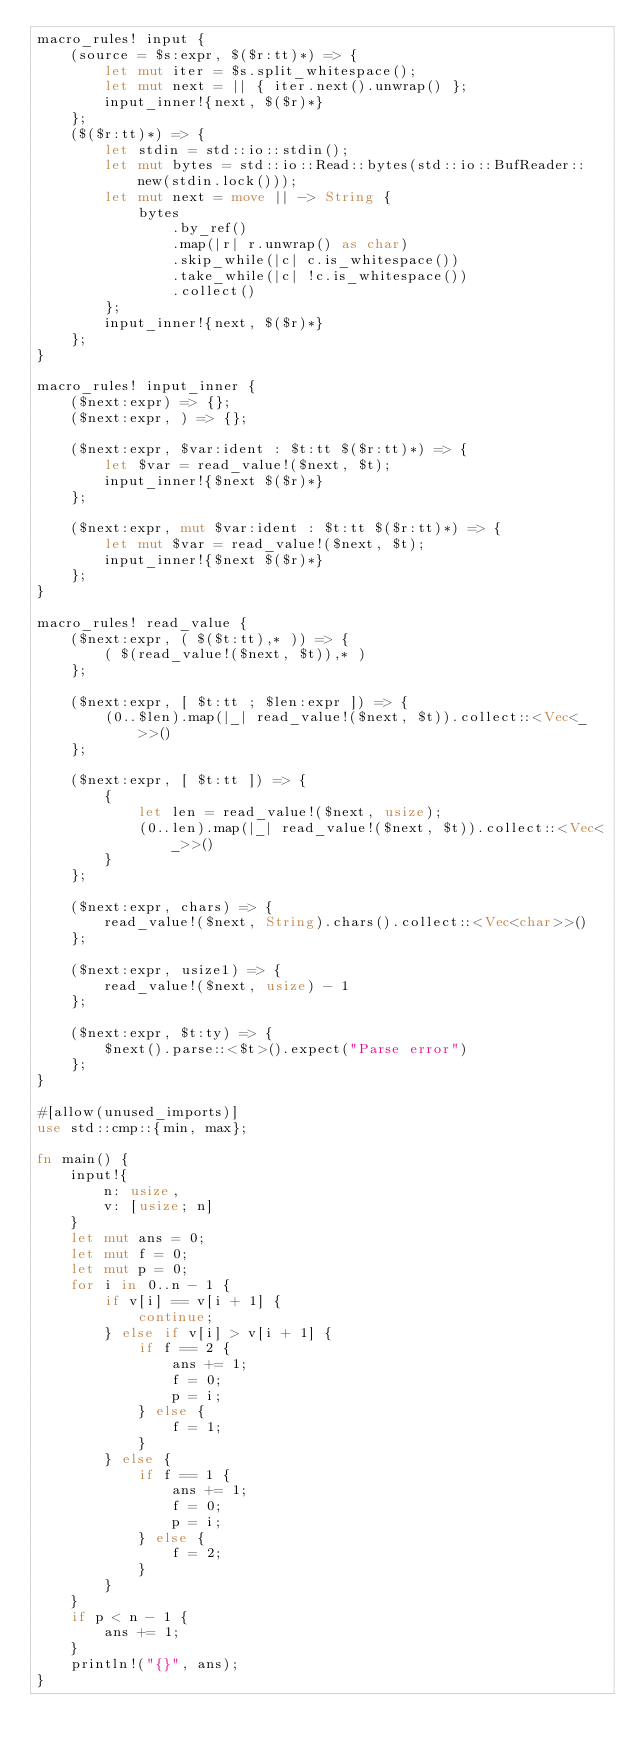<code> <loc_0><loc_0><loc_500><loc_500><_Rust_>macro_rules! input {
    (source = $s:expr, $($r:tt)*) => {
        let mut iter = $s.split_whitespace();
        let mut next = || { iter.next().unwrap() };
        input_inner!{next, $($r)*}
    };
    ($($r:tt)*) => {
        let stdin = std::io::stdin();
        let mut bytes = std::io::Read::bytes(std::io::BufReader::new(stdin.lock()));
        let mut next = move || -> String {
            bytes
                .by_ref()
                .map(|r| r.unwrap() as char)
                .skip_while(|c| c.is_whitespace())
                .take_while(|c| !c.is_whitespace())
                .collect()
        };
        input_inner!{next, $($r)*}
    };
}

macro_rules! input_inner {
    ($next:expr) => {};
    ($next:expr, ) => {};

    ($next:expr, $var:ident : $t:tt $($r:tt)*) => {
        let $var = read_value!($next, $t);
        input_inner!{$next $($r)*}
    };

    ($next:expr, mut $var:ident : $t:tt $($r:tt)*) => {
        let mut $var = read_value!($next, $t);
        input_inner!{$next $($r)*}
    };
}

macro_rules! read_value {
    ($next:expr, ( $($t:tt),* )) => {
        ( $(read_value!($next, $t)),* )
    };

    ($next:expr, [ $t:tt ; $len:expr ]) => {
        (0..$len).map(|_| read_value!($next, $t)).collect::<Vec<_>>()
    };

    ($next:expr, [ $t:tt ]) => {
        {
            let len = read_value!($next, usize);
            (0..len).map(|_| read_value!($next, $t)).collect::<Vec<_>>()
        }
    };

    ($next:expr, chars) => {
        read_value!($next, String).chars().collect::<Vec<char>>()
    };

    ($next:expr, usize1) => {
        read_value!($next, usize) - 1
    };

    ($next:expr, $t:ty) => {
        $next().parse::<$t>().expect("Parse error")
    };
}

#[allow(unused_imports)]
use std::cmp::{min, max};

fn main() {
    input!{
        n: usize,
        v: [usize; n]
    }
    let mut ans = 0;
    let mut f = 0;
    let mut p = 0;
    for i in 0..n - 1 {
        if v[i] == v[i + 1] {
            continue;
        } else if v[i] > v[i + 1] {
            if f == 2 {
                ans += 1;
                f = 0;
                p = i;
            } else {
                f = 1;
            }
        } else {
            if f == 1 {
                ans += 1;
                f = 0;
                p = i;
            } else {
                f = 2;
            }
        }
    }
    if p < n - 1 {
        ans += 1;
    }
    println!("{}", ans);
}
</code> 